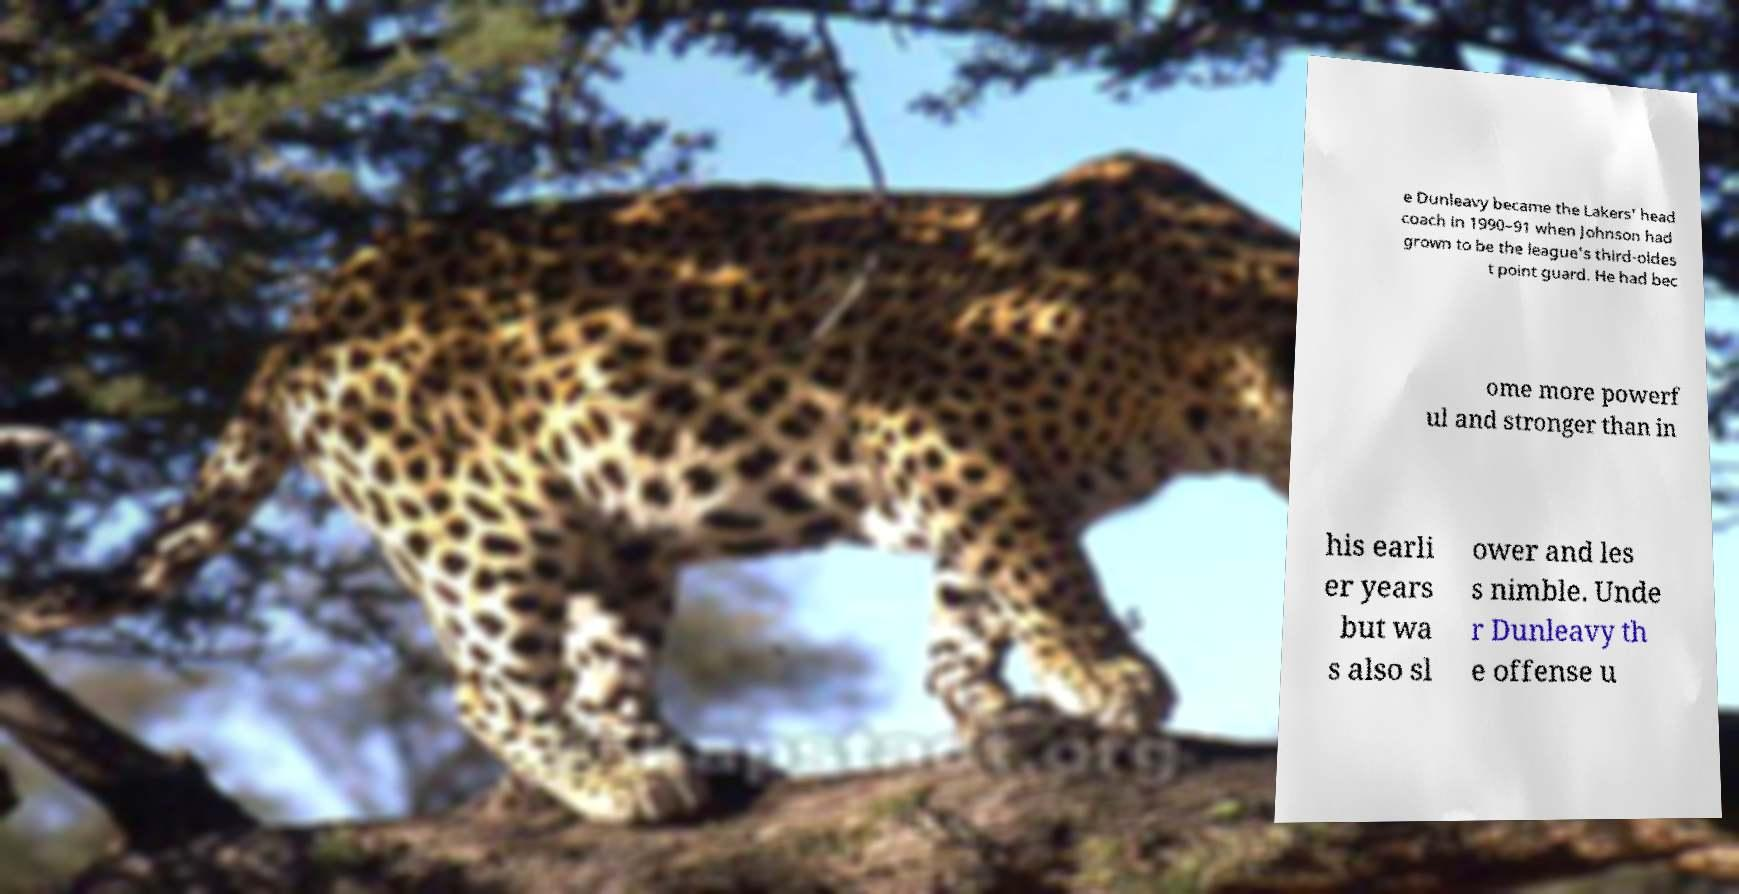Can you accurately transcribe the text from the provided image for me? e Dunleavy became the Lakers' head coach in 1990–91 when Johnson had grown to be the league's third-oldes t point guard. He had bec ome more powerf ul and stronger than in his earli er years but wa s also sl ower and les s nimble. Unde r Dunleavy th e offense u 